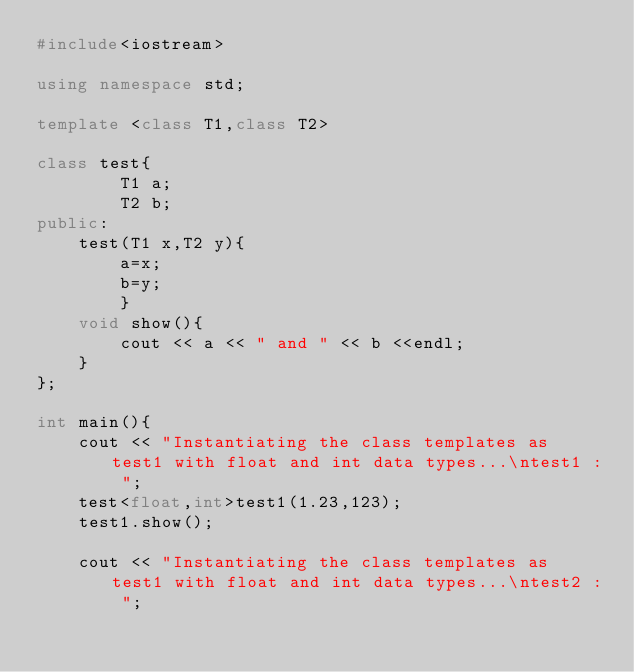<code> <loc_0><loc_0><loc_500><loc_500><_C++_>#include<iostream>

using namespace std;

template <class T1,class T2>

class test{
        T1 a;
        T2 b;
public:
    test(T1 x,T2 y){
        a=x;
        b=y;
        }
    void show(){
        cout << a << " and " << b <<endl;
    }
};

int main(){
    cout << "Instantiating the class templates as test1 with float and int data types...\ntest1 : ";
    test<float,int>test1(1.23,123);
    test1.show();

    cout << "Instantiating the class templates as test1 with float and int data types...\ntest2 : ";</code> 